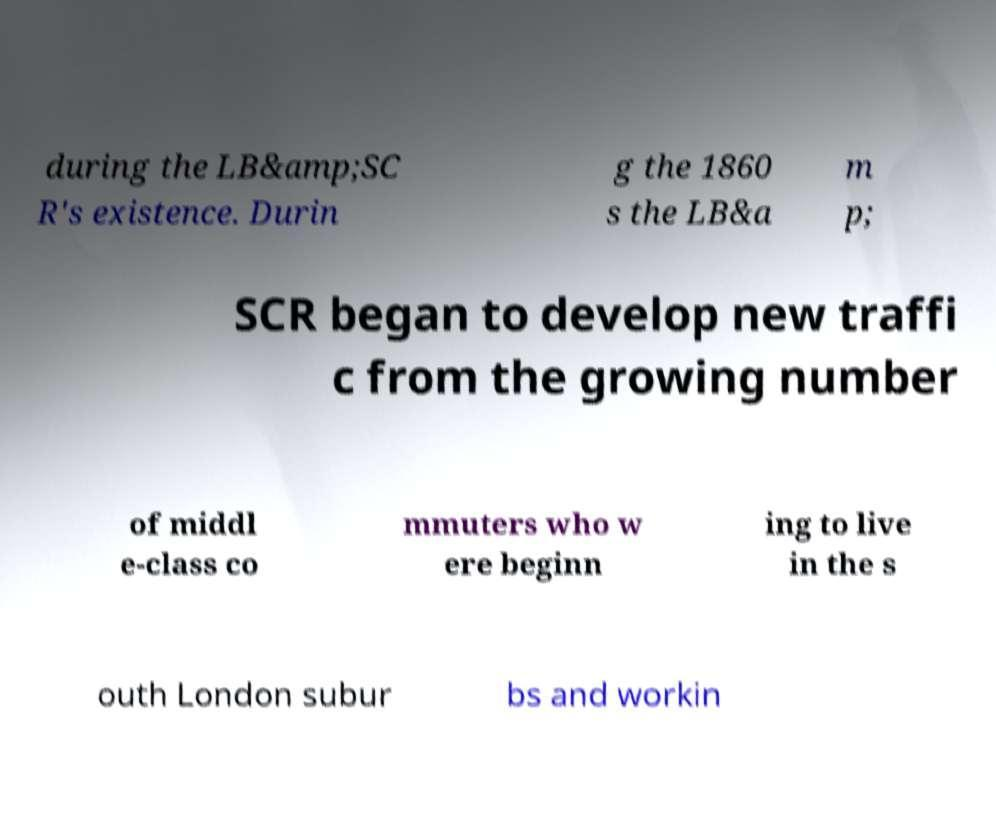Please identify and transcribe the text found in this image. during the LB&amp;SC R's existence. Durin g the 1860 s the LB&a m p; SCR began to develop new traffi c from the growing number of middl e-class co mmuters who w ere beginn ing to live in the s outh London subur bs and workin 